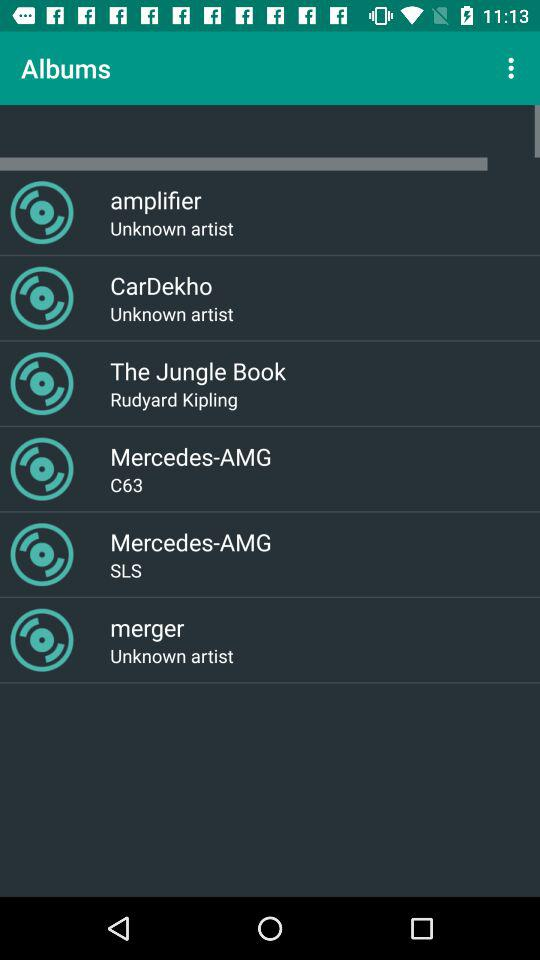Which are the different albums? The different albums are "amplifier", "CarDekho", "The Jungle Book", "Mercedes-AMG", "Mercedes-AMG" and "merger". 